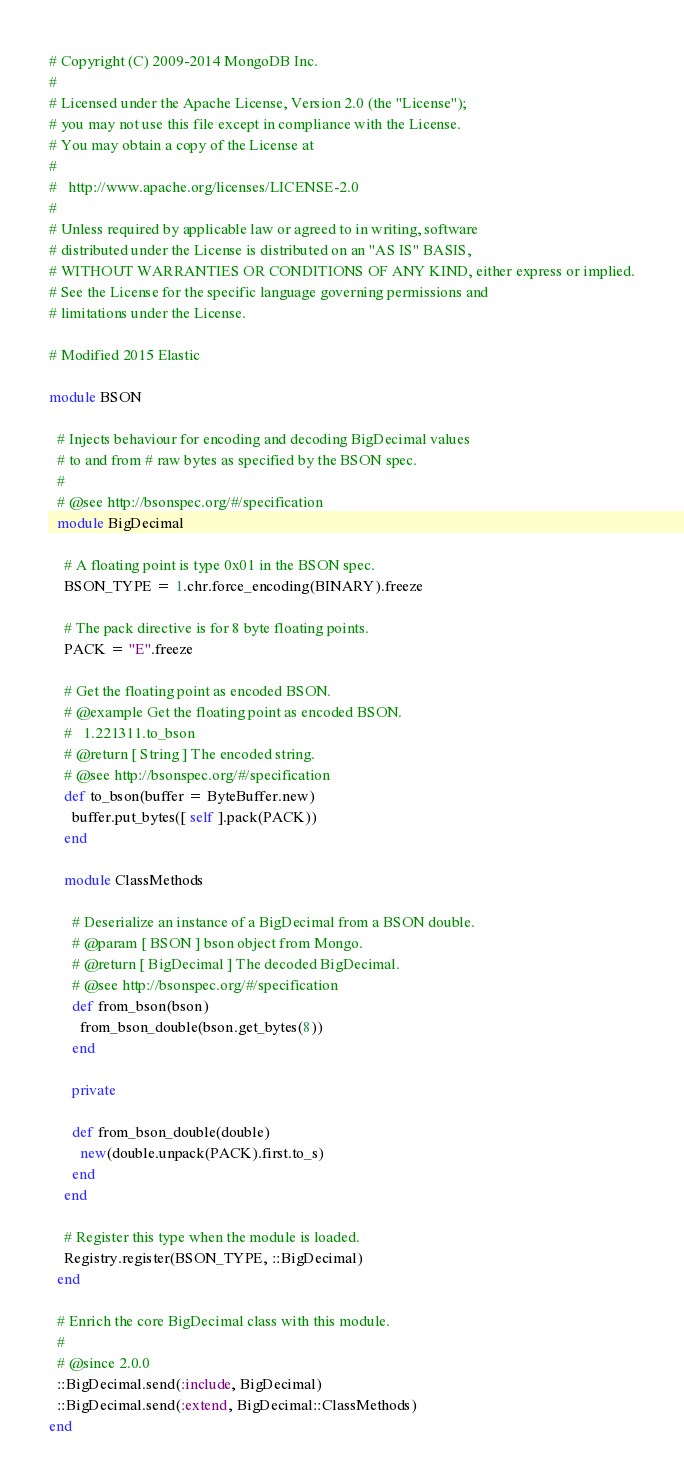Convert code to text. <code><loc_0><loc_0><loc_500><loc_500><_Ruby_># Copyright (C) 2009-2014 MongoDB Inc.
#
# Licensed under the Apache License, Version 2.0 (the "License");
# you may not use this file except in compliance with the License.
# You may obtain a copy of the License at
#
#   http://www.apache.org/licenses/LICENSE-2.0
#
# Unless required by applicable law or agreed to in writing, software
# distributed under the License is distributed on an "AS IS" BASIS,
# WITHOUT WARRANTIES OR CONDITIONS OF ANY KIND, either express or implied.
# See the License for the specific language governing permissions and
# limitations under the License.

# Modified 2015 Elastic

module BSON

  # Injects behaviour for encoding and decoding BigDecimal values
  # to and from # raw bytes as specified by the BSON spec.
  #
  # @see http://bsonspec.org/#/specification
  module BigDecimal

    # A floating point is type 0x01 in the BSON spec.
    BSON_TYPE = 1.chr.force_encoding(BINARY).freeze

    # The pack directive is for 8 byte floating points.
    PACK = "E".freeze

    # Get the floating point as encoded BSON.
    # @example Get the floating point as encoded BSON.
    #   1.221311.to_bson
    # @return [ String ] The encoded string.
    # @see http://bsonspec.org/#/specification
    def to_bson(buffer = ByteBuffer.new)
      buffer.put_bytes([ self ].pack(PACK))	
    end

    module ClassMethods

      # Deserialize an instance of a BigDecimal from a BSON double.
      # @param [ BSON ] bson object from Mongo.
      # @return [ BigDecimal ] The decoded BigDecimal.
      # @see http://bsonspec.org/#/specification
      def from_bson(bson)
        from_bson_double(bson.get_bytes(8))
      end

      private

      def from_bson_double(double)
        new(double.unpack(PACK).first.to_s)
      end
    end

    # Register this type when the module is loaded.
    Registry.register(BSON_TYPE, ::BigDecimal)
  end

  # Enrich the core BigDecimal class with this module.
  #
  # @since 2.0.0
  ::BigDecimal.send(:include, BigDecimal)
  ::BigDecimal.send(:extend, BigDecimal::ClassMethods)
end
</code> 